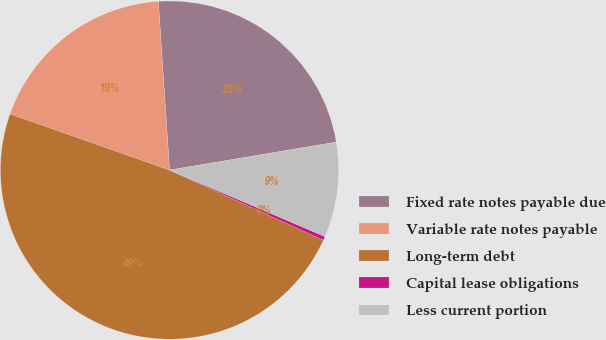Convert chart to OTSL. <chart><loc_0><loc_0><loc_500><loc_500><pie_chart><fcel>Fixed rate notes payable due<fcel>Variable rate notes payable<fcel>Long-term debt<fcel>Capital lease obligations<fcel>Less current portion<nl><fcel>23.41%<fcel>18.57%<fcel>48.57%<fcel>0.37%<fcel>9.08%<nl></chart> 